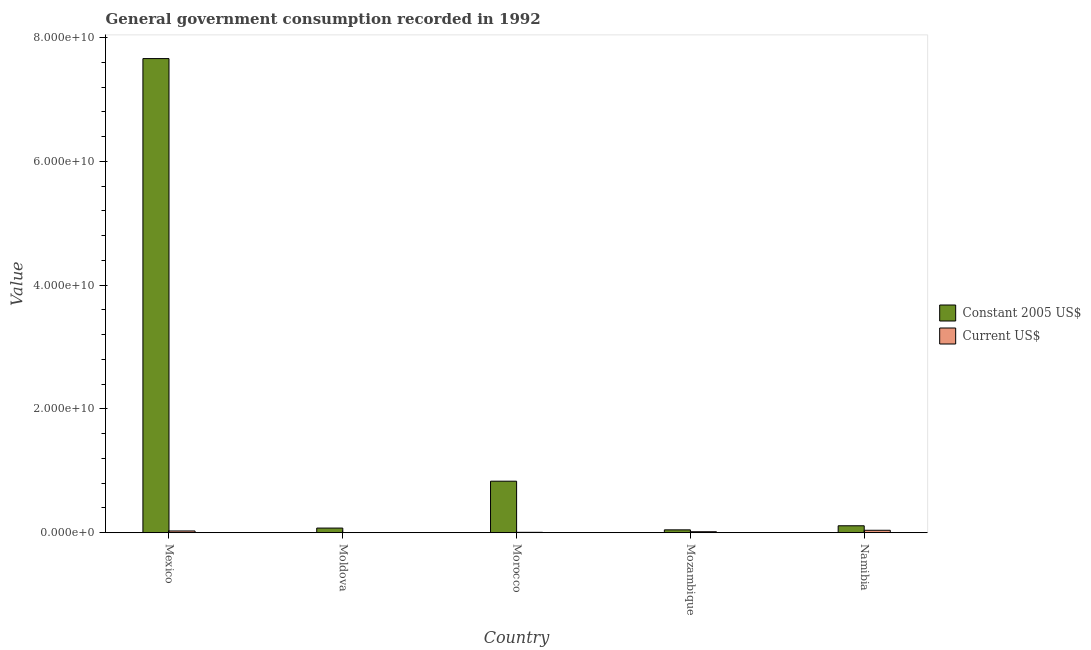How many different coloured bars are there?
Keep it short and to the point. 2. How many groups of bars are there?
Provide a succinct answer. 5. Are the number of bars per tick equal to the number of legend labels?
Your response must be concise. Yes. How many bars are there on the 5th tick from the left?
Your answer should be compact. 2. How many bars are there on the 2nd tick from the right?
Keep it short and to the point. 2. What is the label of the 3rd group of bars from the left?
Give a very brief answer. Morocco. In how many cases, is the number of bars for a given country not equal to the number of legend labels?
Provide a succinct answer. 0. What is the value consumed in current us$ in Namibia?
Your response must be concise. 3.95e+08. Across all countries, what is the maximum value consumed in current us$?
Your response must be concise. 3.95e+08. Across all countries, what is the minimum value consumed in constant 2005 us$?
Ensure brevity in your answer.  4.62e+08. In which country was the value consumed in constant 2005 us$ maximum?
Offer a terse response. Mexico. In which country was the value consumed in constant 2005 us$ minimum?
Offer a terse response. Mozambique. What is the total value consumed in current us$ in the graph?
Your answer should be compact. 9.21e+08. What is the difference between the value consumed in current us$ in Moldova and that in Morocco?
Give a very brief answer. -4.23e+07. What is the difference between the value consumed in current us$ in Moldova and the value consumed in constant 2005 us$ in Namibia?
Give a very brief answer. -1.10e+09. What is the average value consumed in current us$ per country?
Your answer should be compact. 1.84e+08. What is the difference between the value consumed in current us$ and value consumed in constant 2005 us$ in Mozambique?
Your response must be concise. -3.02e+08. What is the ratio of the value consumed in current us$ in Mexico to that in Moldova?
Make the answer very short. 13.97. Is the value consumed in current us$ in Mexico less than that in Mozambique?
Your answer should be compact. No. Is the difference between the value consumed in current us$ in Mexico and Namibia greater than the difference between the value consumed in constant 2005 us$ in Mexico and Namibia?
Give a very brief answer. No. What is the difference between the highest and the second highest value consumed in constant 2005 us$?
Provide a succinct answer. 6.83e+1. What is the difference between the highest and the lowest value consumed in current us$?
Keep it short and to the point. 3.75e+08. In how many countries, is the value consumed in constant 2005 us$ greater than the average value consumed in constant 2005 us$ taken over all countries?
Offer a very short reply. 1. What does the 2nd bar from the left in Mozambique represents?
Offer a very short reply. Current US$. What does the 2nd bar from the right in Mexico represents?
Your answer should be compact. Constant 2005 US$. Are all the bars in the graph horizontal?
Offer a terse response. No. Are the values on the major ticks of Y-axis written in scientific E-notation?
Provide a short and direct response. Yes. Does the graph contain any zero values?
Make the answer very short. No. Where does the legend appear in the graph?
Keep it short and to the point. Center right. What is the title of the graph?
Give a very brief answer. General government consumption recorded in 1992. What is the label or title of the X-axis?
Keep it short and to the point. Country. What is the label or title of the Y-axis?
Make the answer very short. Value. What is the Value of Constant 2005 US$ in Mexico?
Your response must be concise. 7.66e+1. What is the Value of Current US$ in Mexico?
Keep it short and to the point. 2.84e+08. What is the Value of Constant 2005 US$ in Moldova?
Give a very brief answer. 7.48e+08. What is the Value of Current US$ in Moldova?
Provide a succinct answer. 2.03e+07. What is the Value in Constant 2005 US$ in Morocco?
Offer a very short reply. 8.32e+09. What is the Value in Current US$ in Morocco?
Offer a terse response. 6.26e+07. What is the Value in Constant 2005 US$ in Mozambique?
Your answer should be very brief. 4.62e+08. What is the Value of Current US$ in Mozambique?
Provide a succinct answer. 1.60e+08. What is the Value in Constant 2005 US$ in Namibia?
Make the answer very short. 1.12e+09. What is the Value in Current US$ in Namibia?
Offer a very short reply. 3.95e+08. Across all countries, what is the maximum Value in Constant 2005 US$?
Offer a very short reply. 7.66e+1. Across all countries, what is the maximum Value in Current US$?
Your answer should be compact. 3.95e+08. Across all countries, what is the minimum Value in Constant 2005 US$?
Ensure brevity in your answer.  4.62e+08. Across all countries, what is the minimum Value of Current US$?
Offer a very short reply. 2.03e+07. What is the total Value in Constant 2005 US$ in the graph?
Ensure brevity in your answer.  8.73e+1. What is the total Value in Current US$ in the graph?
Your answer should be very brief. 9.21e+08. What is the difference between the Value in Constant 2005 US$ in Mexico and that in Moldova?
Give a very brief answer. 7.59e+1. What is the difference between the Value in Current US$ in Mexico and that in Moldova?
Provide a succinct answer. 2.63e+08. What is the difference between the Value in Constant 2005 US$ in Mexico and that in Morocco?
Your answer should be very brief. 6.83e+1. What is the difference between the Value of Current US$ in Mexico and that in Morocco?
Give a very brief answer. 2.21e+08. What is the difference between the Value of Constant 2005 US$ in Mexico and that in Mozambique?
Provide a succinct answer. 7.61e+1. What is the difference between the Value in Current US$ in Mexico and that in Mozambique?
Provide a succinct answer. 1.24e+08. What is the difference between the Value in Constant 2005 US$ in Mexico and that in Namibia?
Give a very brief answer. 7.55e+1. What is the difference between the Value in Current US$ in Mexico and that in Namibia?
Your response must be concise. -1.11e+08. What is the difference between the Value in Constant 2005 US$ in Moldova and that in Morocco?
Keep it short and to the point. -7.57e+09. What is the difference between the Value in Current US$ in Moldova and that in Morocco?
Give a very brief answer. -4.23e+07. What is the difference between the Value of Constant 2005 US$ in Moldova and that in Mozambique?
Provide a succinct answer. 2.87e+08. What is the difference between the Value of Current US$ in Moldova and that in Mozambique?
Provide a succinct answer. -1.39e+08. What is the difference between the Value of Constant 2005 US$ in Moldova and that in Namibia?
Ensure brevity in your answer.  -3.73e+08. What is the difference between the Value in Current US$ in Moldova and that in Namibia?
Keep it short and to the point. -3.75e+08. What is the difference between the Value of Constant 2005 US$ in Morocco and that in Mozambique?
Provide a short and direct response. 7.86e+09. What is the difference between the Value in Current US$ in Morocco and that in Mozambique?
Ensure brevity in your answer.  -9.72e+07. What is the difference between the Value in Constant 2005 US$ in Morocco and that in Namibia?
Your answer should be compact. 7.20e+09. What is the difference between the Value in Current US$ in Morocco and that in Namibia?
Offer a very short reply. -3.32e+08. What is the difference between the Value of Constant 2005 US$ in Mozambique and that in Namibia?
Make the answer very short. -6.60e+08. What is the difference between the Value in Current US$ in Mozambique and that in Namibia?
Your answer should be compact. -2.35e+08. What is the difference between the Value of Constant 2005 US$ in Mexico and the Value of Current US$ in Moldova?
Your response must be concise. 7.66e+1. What is the difference between the Value in Constant 2005 US$ in Mexico and the Value in Current US$ in Morocco?
Your response must be concise. 7.65e+1. What is the difference between the Value of Constant 2005 US$ in Mexico and the Value of Current US$ in Mozambique?
Your answer should be very brief. 7.64e+1. What is the difference between the Value of Constant 2005 US$ in Mexico and the Value of Current US$ in Namibia?
Ensure brevity in your answer.  7.62e+1. What is the difference between the Value in Constant 2005 US$ in Moldova and the Value in Current US$ in Morocco?
Your answer should be compact. 6.86e+08. What is the difference between the Value of Constant 2005 US$ in Moldova and the Value of Current US$ in Mozambique?
Your answer should be very brief. 5.89e+08. What is the difference between the Value in Constant 2005 US$ in Moldova and the Value in Current US$ in Namibia?
Offer a very short reply. 3.54e+08. What is the difference between the Value in Constant 2005 US$ in Morocco and the Value in Current US$ in Mozambique?
Give a very brief answer. 8.16e+09. What is the difference between the Value of Constant 2005 US$ in Morocco and the Value of Current US$ in Namibia?
Provide a succinct answer. 7.93e+09. What is the difference between the Value in Constant 2005 US$ in Mozambique and the Value in Current US$ in Namibia?
Ensure brevity in your answer.  6.70e+07. What is the average Value of Constant 2005 US$ per country?
Keep it short and to the point. 1.75e+1. What is the average Value in Current US$ per country?
Your response must be concise. 1.84e+08. What is the difference between the Value in Constant 2005 US$ and Value in Current US$ in Mexico?
Provide a succinct answer. 7.63e+1. What is the difference between the Value in Constant 2005 US$ and Value in Current US$ in Moldova?
Offer a terse response. 7.28e+08. What is the difference between the Value in Constant 2005 US$ and Value in Current US$ in Morocco?
Keep it short and to the point. 8.26e+09. What is the difference between the Value of Constant 2005 US$ and Value of Current US$ in Mozambique?
Keep it short and to the point. 3.02e+08. What is the difference between the Value in Constant 2005 US$ and Value in Current US$ in Namibia?
Your answer should be very brief. 7.27e+08. What is the ratio of the Value in Constant 2005 US$ in Mexico to that in Moldova?
Provide a short and direct response. 102.35. What is the ratio of the Value of Current US$ in Mexico to that in Moldova?
Ensure brevity in your answer.  13.97. What is the ratio of the Value in Constant 2005 US$ in Mexico to that in Morocco?
Ensure brevity in your answer.  9.2. What is the ratio of the Value in Current US$ in Mexico to that in Morocco?
Your answer should be compact. 4.54. What is the ratio of the Value of Constant 2005 US$ in Mexico to that in Mozambique?
Make the answer very short. 165.83. What is the ratio of the Value in Current US$ in Mexico to that in Mozambique?
Give a very brief answer. 1.78. What is the ratio of the Value in Constant 2005 US$ in Mexico to that in Namibia?
Your answer should be compact. 68.3. What is the ratio of the Value of Current US$ in Mexico to that in Namibia?
Your answer should be compact. 0.72. What is the ratio of the Value of Constant 2005 US$ in Moldova to that in Morocco?
Offer a very short reply. 0.09. What is the ratio of the Value in Current US$ in Moldova to that in Morocco?
Your answer should be compact. 0.32. What is the ratio of the Value in Constant 2005 US$ in Moldova to that in Mozambique?
Offer a terse response. 1.62. What is the ratio of the Value of Current US$ in Moldova to that in Mozambique?
Provide a succinct answer. 0.13. What is the ratio of the Value of Constant 2005 US$ in Moldova to that in Namibia?
Provide a short and direct response. 0.67. What is the ratio of the Value in Current US$ in Moldova to that in Namibia?
Ensure brevity in your answer.  0.05. What is the ratio of the Value in Constant 2005 US$ in Morocco to that in Mozambique?
Your answer should be very brief. 18.02. What is the ratio of the Value in Current US$ in Morocco to that in Mozambique?
Provide a succinct answer. 0.39. What is the ratio of the Value of Constant 2005 US$ in Morocco to that in Namibia?
Offer a terse response. 7.42. What is the ratio of the Value of Current US$ in Morocco to that in Namibia?
Your answer should be compact. 0.16. What is the ratio of the Value in Constant 2005 US$ in Mozambique to that in Namibia?
Offer a terse response. 0.41. What is the ratio of the Value of Current US$ in Mozambique to that in Namibia?
Give a very brief answer. 0.4. What is the difference between the highest and the second highest Value in Constant 2005 US$?
Make the answer very short. 6.83e+1. What is the difference between the highest and the second highest Value of Current US$?
Give a very brief answer. 1.11e+08. What is the difference between the highest and the lowest Value in Constant 2005 US$?
Offer a very short reply. 7.61e+1. What is the difference between the highest and the lowest Value of Current US$?
Provide a short and direct response. 3.75e+08. 